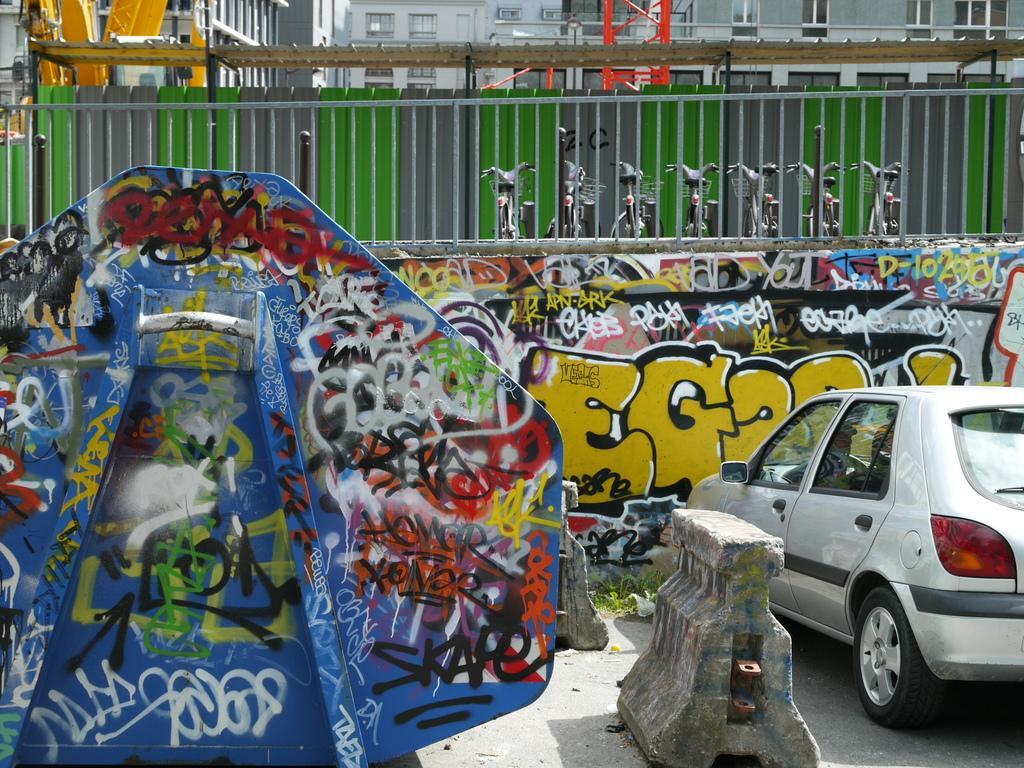Can you describe this image briefly? On the right side of the image there is a car. On the left we can see a board. In the background there is a wall and we can see graffiti on it. At the top there are buildings and we can see fence. There are bicycles. 